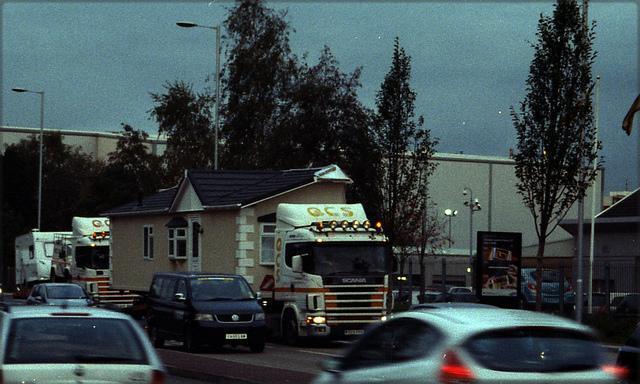How many cars are in the picture?
Give a very brief answer. 3. How many trucks are visible?
Give a very brief answer. 2. 